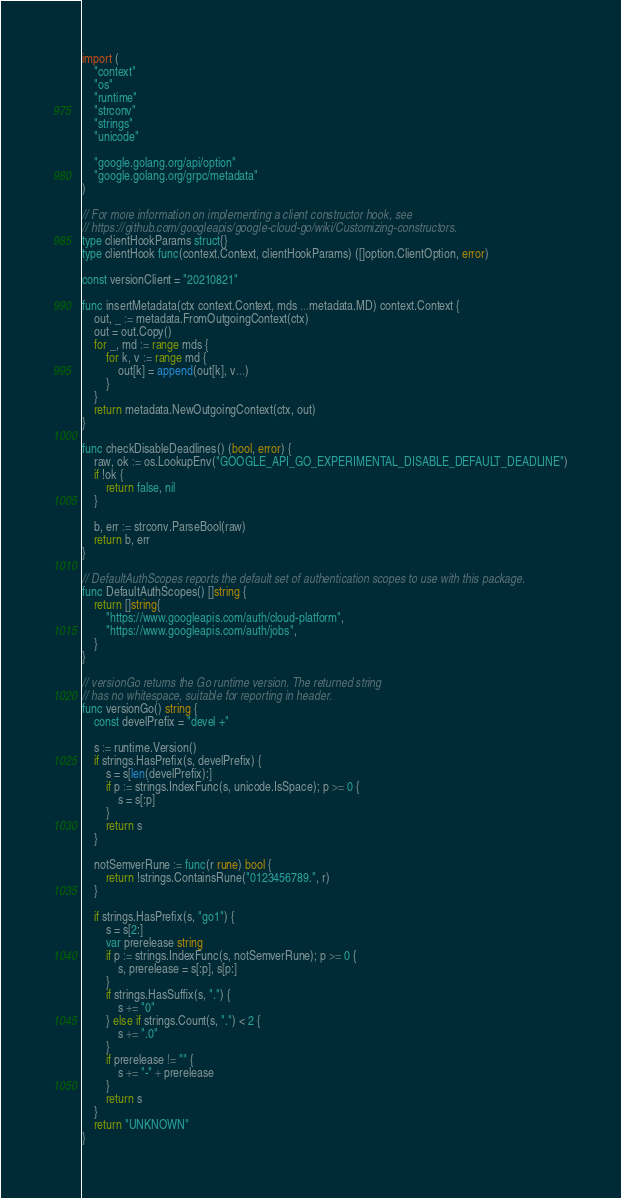Convert code to text. <code><loc_0><loc_0><loc_500><loc_500><_Go_>import (
	"context"
	"os"
	"runtime"
	"strconv"
	"strings"
	"unicode"

	"google.golang.org/api/option"
	"google.golang.org/grpc/metadata"
)

// For more information on implementing a client constructor hook, see
// https://github.com/googleapis/google-cloud-go/wiki/Customizing-constructors.
type clientHookParams struct{}
type clientHook func(context.Context, clientHookParams) ([]option.ClientOption, error)

const versionClient = "20210821"

func insertMetadata(ctx context.Context, mds ...metadata.MD) context.Context {
	out, _ := metadata.FromOutgoingContext(ctx)
	out = out.Copy()
	for _, md := range mds {
		for k, v := range md {
			out[k] = append(out[k], v...)
		}
	}
	return metadata.NewOutgoingContext(ctx, out)
}

func checkDisableDeadlines() (bool, error) {
	raw, ok := os.LookupEnv("GOOGLE_API_GO_EXPERIMENTAL_DISABLE_DEFAULT_DEADLINE")
	if !ok {
		return false, nil
	}

	b, err := strconv.ParseBool(raw)
	return b, err
}

// DefaultAuthScopes reports the default set of authentication scopes to use with this package.
func DefaultAuthScopes() []string {
	return []string{
		"https://www.googleapis.com/auth/cloud-platform",
		"https://www.googleapis.com/auth/jobs",
	}
}

// versionGo returns the Go runtime version. The returned string
// has no whitespace, suitable for reporting in header.
func versionGo() string {
	const develPrefix = "devel +"

	s := runtime.Version()
	if strings.HasPrefix(s, develPrefix) {
		s = s[len(develPrefix):]
		if p := strings.IndexFunc(s, unicode.IsSpace); p >= 0 {
			s = s[:p]
		}
		return s
	}

	notSemverRune := func(r rune) bool {
		return !strings.ContainsRune("0123456789.", r)
	}

	if strings.HasPrefix(s, "go1") {
		s = s[2:]
		var prerelease string
		if p := strings.IndexFunc(s, notSemverRune); p >= 0 {
			s, prerelease = s[:p], s[p:]
		}
		if strings.HasSuffix(s, ".") {
			s += "0"
		} else if strings.Count(s, ".") < 2 {
			s += ".0"
		}
		if prerelease != "" {
			s += "-" + prerelease
		}
		return s
	}
	return "UNKNOWN"
}
</code> 